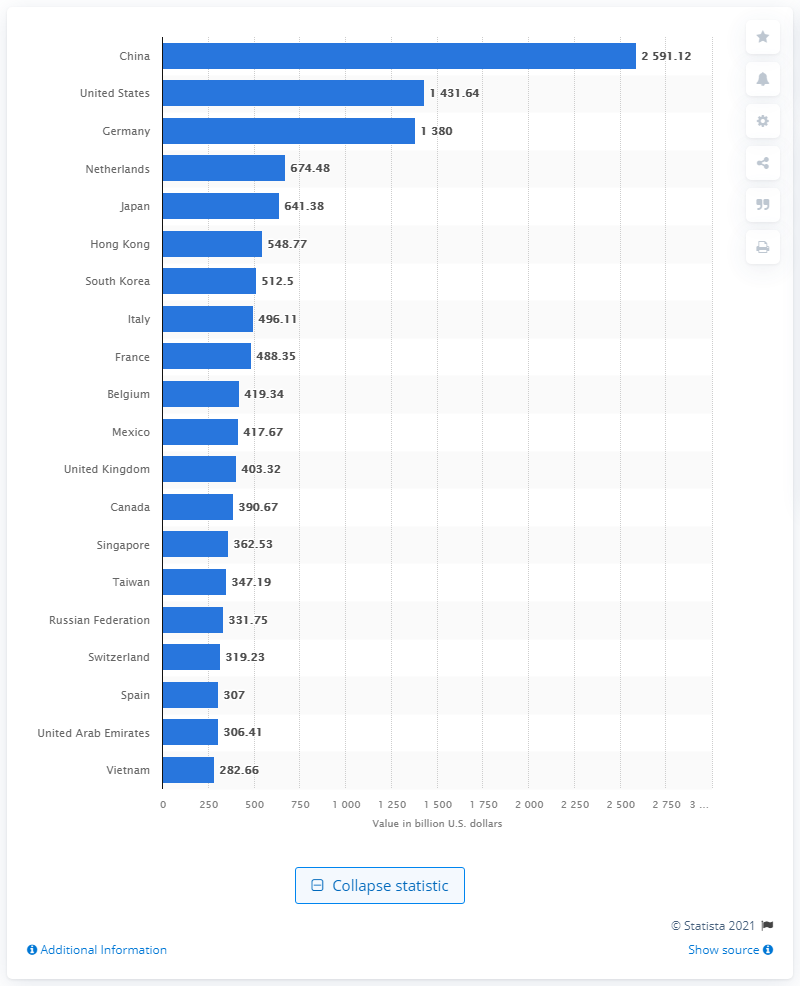Identify some key points in this picture. In 2020, the value of China's exports in dollars was 2591.12. 